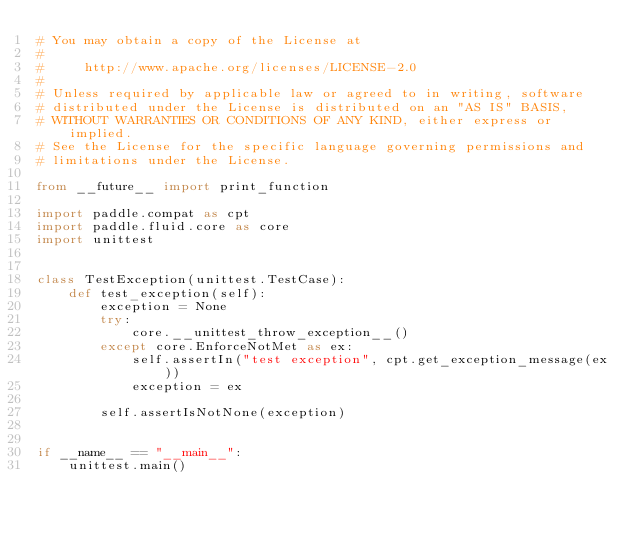<code> <loc_0><loc_0><loc_500><loc_500><_Python_># You may obtain a copy of the License at
#
#     http://www.apache.org/licenses/LICENSE-2.0
#
# Unless required by applicable law or agreed to in writing, software
# distributed under the License is distributed on an "AS IS" BASIS,
# WITHOUT WARRANTIES OR CONDITIONS OF ANY KIND, either express or implied.
# See the License for the specific language governing permissions and
# limitations under the License.

from __future__ import print_function

import paddle.compat as cpt
import paddle.fluid.core as core
import unittest


class TestException(unittest.TestCase):
    def test_exception(self):
        exception = None
        try:
            core.__unittest_throw_exception__()
        except core.EnforceNotMet as ex:
            self.assertIn("test exception", cpt.get_exception_message(ex))
            exception = ex

        self.assertIsNotNone(exception)


if __name__ == "__main__":
    unittest.main()
</code> 